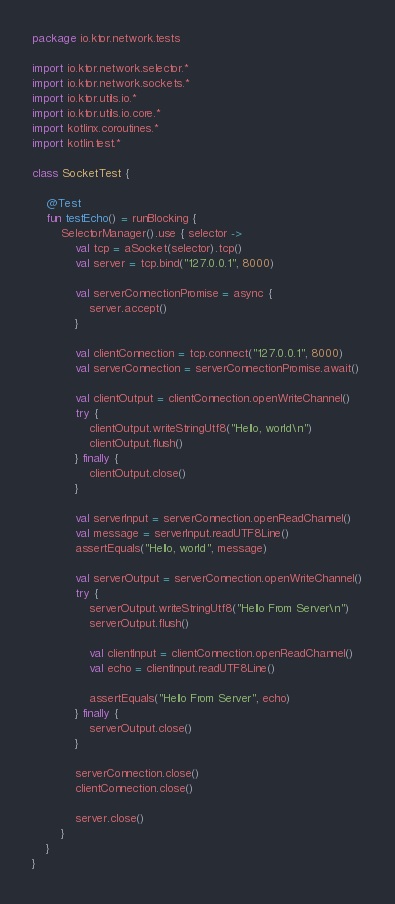<code> <loc_0><loc_0><loc_500><loc_500><_Kotlin_>package io.ktor.network.tests

import io.ktor.network.selector.*
import io.ktor.network.sockets.*
import io.ktor.utils.io.*
import io.ktor.utils.io.core.*
import kotlinx.coroutines.*
import kotlin.test.*

class SocketTest {

    @Test
    fun testEcho() = runBlocking {
        SelectorManager().use { selector ->
            val tcp = aSocket(selector).tcp()
            val server = tcp.bind("127.0.0.1", 8000)

            val serverConnectionPromise = async {
                server.accept()
            }

            val clientConnection = tcp.connect("127.0.0.1", 8000)
            val serverConnection = serverConnectionPromise.await()

            val clientOutput = clientConnection.openWriteChannel()
            try {
                clientOutput.writeStringUtf8("Hello, world\n")
                clientOutput.flush()
            } finally {
                clientOutput.close()
            }

            val serverInput = serverConnection.openReadChannel()
            val message = serverInput.readUTF8Line()
            assertEquals("Hello, world", message)

            val serverOutput = serverConnection.openWriteChannel()
            try {
                serverOutput.writeStringUtf8("Hello From Server\n")
                serverOutput.flush()

                val clientInput = clientConnection.openReadChannel()
                val echo = clientInput.readUTF8Line()

                assertEquals("Hello From Server", echo)
            } finally {
                serverOutput.close()
            }

            serverConnection.close()
            clientConnection.close()

            server.close()
        }
    }
}
</code> 